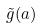<formula> <loc_0><loc_0><loc_500><loc_500>\tilde { g } ( a )</formula> 